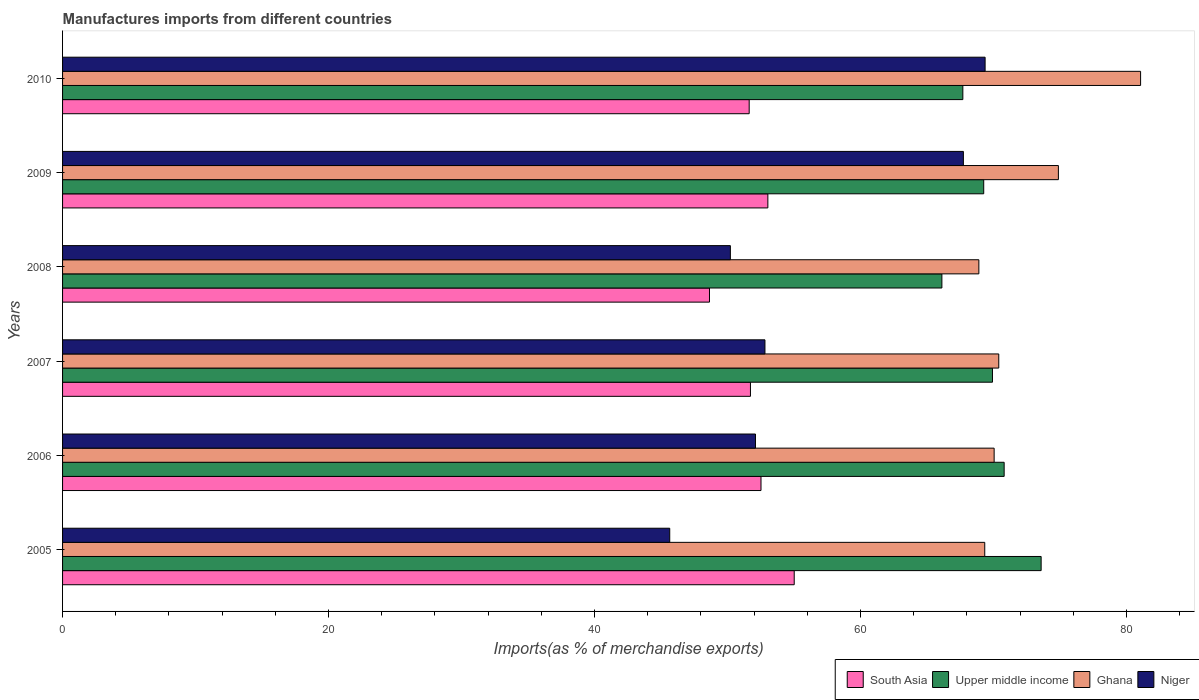How many groups of bars are there?
Your answer should be compact. 6. Are the number of bars per tick equal to the number of legend labels?
Give a very brief answer. Yes. What is the label of the 1st group of bars from the top?
Make the answer very short. 2010. What is the percentage of imports to different countries in Upper middle income in 2010?
Give a very brief answer. 67.7. Across all years, what is the maximum percentage of imports to different countries in Niger?
Keep it short and to the point. 69.37. Across all years, what is the minimum percentage of imports to different countries in South Asia?
Your answer should be very brief. 48.64. In which year was the percentage of imports to different countries in South Asia minimum?
Make the answer very short. 2008. What is the total percentage of imports to different countries in Ghana in the graph?
Keep it short and to the point. 434.63. What is the difference between the percentage of imports to different countries in South Asia in 2005 and that in 2009?
Give a very brief answer. 1.98. What is the difference between the percentage of imports to different countries in Ghana in 2006 and the percentage of imports to different countries in Niger in 2008?
Your answer should be very brief. 19.83. What is the average percentage of imports to different countries in Upper middle income per year?
Offer a very short reply. 69.56. In the year 2006, what is the difference between the percentage of imports to different countries in Ghana and percentage of imports to different countries in Upper middle income?
Keep it short and to the point. -0.75. In how many years, is the percentage of imports to different countries in Ghana greater than 64 %?
Give a very brief answer. 6. What is the ratio of the percentage of imports to different countries in Upper middle income in 2006 to that in 2008?
Provide a short and direct response. 1.07. Is the percentage of imports to different countries in Ghana in 2005 less than that in 2008?
Your answer should be compact. No. What is the difference between the highest and the second highest percentage of imports to different countries in South Asia?
Offer a terse response. 1.98. What is the difference between the highest and the lowest percentage of imports to different countries in Ghana?
Your response must be concise. 12.16. Is it the case that in every year, the sum of the percentage of imports to different countries in South Asia and percentage of imports to different countries in Upper middle income is greater than the sum of percentage of imports to different countries in Ghana and percentage of imports to different countries in Niger?
Make the answer very short. No. What does the 1st bar from the top in 2010 represents?
Offer a terse response. Niger. What does the 2nd bar from the bottom in 2009 represents?
Your answer should be compact. Upper middle income. How many bars are there?
Your response must be concise. 24. What is the difference between two consecutive major ticks on the X-axis?
Your answer should be compact. 20. Are the values on the major ticks of X-axis written in scientific E-notation?
Offer a very short reply. No. Does the graph contain any zero values?
Keep it short and to the point. No. Where does the legend appear in the graph?
Your response must be concise. Bottom right. What is the title of the graph?
Your answer should be very brief. Manufactures imports from different countries. Does "Georgia" appear as one of the legend labels in the graph?
Provide a succinct answer. No. What is the label or title of the X-axis?
Your answer should be compact. Imports(as % of merchandise exports). What is the Imports(as % of merchandise exports) of South Asia in 2005?
Provide a short and direct response. 55.02. What is the Imports(as % of merchandise exports) in Upper middle income in 2005?
Offer a terse response. 73.58. What is the Imports(as % of merchandise exports) of Ghana in 2005?
Ensure brevity in your answer.  69.34. What is the Imports(as % of merchandise exports) of Niger in 2005?
Offer a terse response. 45.66. What is the Imports(as % of merchandise exports) of South Asia in 2006?
Your response must be concise. 52.52. What is the Imports(as % of merchandise exports) of Upper middle income in 2006?
Keep it short and to the point. 70.8. What is the Imports(as % of merchandise exports) of Ghana in 2006?
Your answer should be compact. 70.05. What is the Imports(as % of merchandise exports) in Niger in 2006?
Provide a short and direct response. 52.1. What is the Imports(as % of merchandise exports) of South Asia in 2007?
Your answer should be very brief. 51.72. What is the Imports(as % of merchandise exports) in Upper middle income in 2007?
Make the answer very short. 69.92. What is the Imports(as % of merchandise exports) of Ghana in 2007?
Your response must be concise. 70.4. What is the Imports(as % of merchandise exports) of Niger in 2007?
Offer a very short reply. 52.82. What is the Imports(as % of merchandise exports) in South Asia in 2008?
Ensure brevity in your answer.  48.64. What is the Imports(as % of merchandise exports) in Upper middle income in 2008?
Offer a terse response. 66.12. What is the Imports(as % of merchandise exports) in Ghana in 2008?
Your response must be concise. 68.9. What is the Imports(as % of merchandise exports) of Niger in 2008?
Keep it short and to the point. 50.22. What is the Imports(as % of merchandise exports) in South Asia in 2009?
Give a very brief answer. 53.03. What is the Imports(as % of merchandise exports) in Upper middle income in 2009?
Provide a short and direct response. 69.27. What is the Imports(as % of merchandise exports) in Ghana in 2009?
Make the answer very short. 74.88. What is the Imports(as % of merchandise exports) of Niger in 2009?
Offer a terse response. 67.74. What is the Imports(as % of merchandise exports) in South Asia in 2010?
Your answer should be compact. 51.63. What is the Imports(as % of merchandise exports) of Upper middle income in 2010?
Provide a succinct answer. 67.7. What is the Imports(as % of merchandise exports) of Ghana in 2010?
Keep it short and to the point. 81.06. What is the Imports(as % of merchandise exports) in Niger in 2010?
Give a very brief answer. 69.37. Across all years, what is the maximum Imports(as % of merchandise exports) in South Asia?
Offer a terse response. 55.02. Across all years, what is the maximum Imports(as % of merchandise exports) of Upper middle income?
Make the answer very short. 73.58. Across all years, what is the maximum Imports(as % of merchandise exports) of Ghana?
Your answer should be very brief. 81.06. Across all years, what is the maximum Imports(as % of merchandise exports) in Niger?
Provide a short and direct response. 69.37. Across all years, what is the minimum Imports(as % of merchandise exports) of South Asia?
Your response must be concise. 48.64. Across all years, what is the minimum Imports(as % of merchandise exports) in Upper middle income?
Your answer should be compact. 66.12. Across all years, what is the minimum Imports(as % of merchandise exports) of Ghana?
Provide a succinct answer. 68.9. Across all years, what is the minimum Imports(as % of merchandise exports) of Niger?
Provide a short and direct response. 45.66. What is the total Imports(as % of merchandise exports) of South Asia in the graph?
Provide a succinct answer. 312.57. What is the total Imports(as % of merchandise exports) in Upper middle income in the graph?
Your response must be concise. 417.39. What is the total Imports(as % of merchandise exports) of Ghana in the graph?
Your answer should be very brief. 434.63. What is the total Imports(as % of merchandise exports) in Niger in the graph?
Give a very brief answer. 337.9. What is the difference between the Imports(as % of merchandise exports) of South Asia in 2005 and that in 2006?
Your answer should be very brief. 2.5. What is the difference between the Imports(as % of merchandise exports) in Upper middle income in 2005 and that in 2006?
Ensure brevity in your answer.  2.78. What is the difference between the Imports(as % of merchandise exports) of Ghana in 2005 and that in 2006?
Offer a terse response. -0.71. What is the difference between the Imports(as % of merchandise exports) in Niger in 2005 and that in 2006?
Give a very brief answer. -6.45. What is the difference between the Imports(as % of merchandise exports) in South Asia in 2005 and that in 2007?
Offer a terse response. 3.29. What is the difference between the Imports(as % of merchandise exports) of Upper middle income in 2005 and that in 2007?
Your response must be concise. 3.66. What is the difference between the Imports(as % of merchandise exports) in Ghana in 2005 and that in 2007?
Offer a very short reply. -1.05. What is the difference between the Imports(as % of merchandise exports) in Niger in 2005 and that in 2007?
Your answer should be very brief. -7.16. What is the difference between the Imports(as % of merchandise exports) in South Asia in 2005 and that in 2008?
Make the answer very short. 6.37. What is the difference between the Imports(as % of merchandise exports) in Upper middle income in 2005 and that in 2008?
Make the answer very short. 7.46. What is the difference between the Imports(as % of merchandise exports) of Ghana in 2005 and that in 2008?
Give a very brief answer. 0.44. What is the difference between the Imports(as % of merchandise exports) in Niger in 2005 and that in 2008?
Keep it short and to the point. -4.56. What is the difference between the Imports(as % of merchandise exports) of South Asia in 2005 and that in 2009?
Your answer should be very brief. 1.98. What is the difference between the Imports(as % of merchandise exports) of Upper middle income in 2005 and that in 2009?
Provide a short and direct response. 4.32. What is the difference between the Imports(as % of merchandise exports) in Ghana in 2005 and that in 2009?
Provide a short and direct response. -5.54. What is the difference between the Imports(as % of merchandise exports) in Niger in 2005 and that in 2009?
Offer a terse response. -22.08. What is the difference between the Imports(as % of merchandise exports) in South Asia in 2005 and that in 2010?
Offer a terse response. 3.39. What is the difference between the Imports(as % of merchandise exports) of Upper middle income in 2005 and that in 2010?
Your response must be concise. 5.89. What is the difference between the Imports(as % of merchandise exports) of Ghana in 2005 and that in 2010?
Your response must be concise. -11.72. What is the difference between the Imports(as % of merchandise exports) in Niger in 2005 and that in 2010?
Keep it short and to the point. -23.71. What is the difference between the Imports(as % of merchandise exports) of South Asia in 2006 and that in 2007?
Make the answer very short. 0.79. What is the difference between the Imports(as % of merchandise exports) in Upper middle income in 2006 and that in 2007?
Offer a very short reply. 0.88. What is the difference between the Imports(as % of merchandise exports) of Ghana in 2006 and that in 2007?
Offer a terse response. -0.35. What is the difference between the Imports(as % of merchandise exports) of Niger in 2006 and that in 2007?
Keep it short and to the point. -0.71. What is the difference between the Imports(as % of merchandise exports) in South Asia in 2006 and that in 2008?
Give a very brief answer. 3.87. What is the difference between the Imports(as % of merchandise exports) in Upper middle income in 2006 and that in 2008?
Give a very brief answer. 4.68. What is the difference between the Imports(as % of merchandise exports) of Ghana in 2006 and that in 2008?
Your response must be concise. 1.15. What is the difference between the Imports(as % of merchandise exports) of Niger in 2006 and that in 2008?
Give a very brief answer. 1.89. What is the difference between the Imports(as % of merchandise exports) of South Asia in 2006 and that in 2009?
Offer a terse response. -0.52. What is the difference between the Imports(as % of merchandise exports) of Upper middle income in 2006 and that in 2009?
Your response must be concise. 1.54. What is the difference between the Imports(as % of merchandise exports) in Ghana in 2006 and that in 2009?
Ensure brevity in your answer.  -4.83. What is the difference between the Imports(as % of merchandise exports) of Niger in 2006 and that in 2009?
Provide a succinct answer. -15.63. What is the difference between the Imports(as % of merchandise exports) in South Asia in 2006 and that in 2010?
Offer a very short reply. 0.89. What is the difference between the Imports(as % of merchandise exports) in Upper middle income in 2006 and that in 2010?
Give a very brief answer. 3.11. What is the difference between the Imports(as % of merchandise exports) in Ghana in 2006 and that in 2010?
Your answer should be compact. -11.01. What is the difference between the Imports(as % of merchandise exports) of Niger in 2006 and that in 2010?
Make the answer very short. -17.27. What is the difference between the Imports(as % of merchandise exports) in South Asia in 2007 and that in 2008?
Offer a very short reply. 3.08. What is the difference between the Imports(as % of merchandise exports) in Upper middle income in 2007 and that in 2008?
Provide a succinct answer. 3.8. What is the difference between the Imports(as % of merchandise exports) in Ghana in 2007 and that in 2008?
Provide a short and direct response. 1.5. What is the difference between the Imports(as % of merchandise exports) in Niger in 2007 and that in 2008?
Provide a short and direct response. 2.6. What is the difference between the Imports(as % of merchandise exports) of South Asia in 2007 and that in 2009?
Keep it short and to the point. -1.31. What is the difference between the Imports(as % of merchandise exports) of Upper middle income in 2007 and that in 2009?
Make the answer very short. 0.66. What is the difference between the Imports(as % of merchandise exports) in Ghana in 2007 and that in 2009?
Your answer should be very brief. -4.48. What is the difference between the Imports(as % of merchandise exports) of Niger in 2007 and that in 2009?
Provide a short and direct response. -14.92. What is the difference between the Imports(as % of merchandise exports) of South Asia in 2007 and that in 2010?
Your answer should be compact. 0.09. What is the difference between the Imports(as % of merchandise exports) in Upper middle income in 2007 and that in 2010?
Your response must be concise. 2.23. What is the difference between the Imports(as % of merchandise exports) in Ghana in 2007 and that in 2010?
Offer a terse response. -10.66. What is the difference between the Imports(as % of merchandise exports) of Niger in 2007 and that in 2010?
Provide a short and direct response. -16.55. What is the difference between the Imports(as % of merchandise exports) of South Asia in 2008 and that in 2009?
Your answer should be very brief. -4.39. What is the difference between the Imports(as % of merchandise exports) in Upper middle income in 2008 and that in 2009?
Your response must be concise. -3.15. What is the difference between the Imports(as % of merchandise exports) in Ghana in 2008 and that in 2009?
Offer a terse response. -5.98. What is the difference between the Imports(as % of merchandise exports) in Niger in 2008 and that in 2009?
Your response must be concise. -17.52. What is the difference between the Imports(as % of merchandise exports) in South Asia in 2008 and that in 2010?
Your answer should be very brief. -2.99. What is the difference between the Imports(as % of merchandise exports) of Upper middle income in 2008 and that in 2010?
Provide a short and direct response. -1.58. What is the difference between the Imports(as % of merchandise exports) of Ghana in 2008 and that in 2010?
Offer a very short reply. -12.16. What is the difference between the Imports(as % of merchandise exports) of Niger in 2008 and that in 2010?
Ensure brevity in your answer.  -19.15. What is the difference between the Imports(as % of merchandise exports) of South Asia in 2009 and that in 2010?
Keep it short and to the point. 1.4. What is the difference between the Imports(as % of merchandise exports) of Upper middle income in 2009 and that in 2010?
Give a very brief answer. 1.57. What is the difference between the Imports(as % of merchandise exports) of Ghana in 2009 and that in 2010?
Ensure brevity in your answer.  -6.18. What is the difference between the Imports(as % of merchandise exports) of Niger in 2009 and that in 2010?
Your answer should be very brief. -1.63. What is the difference between the Imports(as % of merchandise exports) of South Asia in 2005 and the Imports(as % of merchandise exports) of Upper middle income in 2006?
Provide a succinct answer. -15.79. What is the difference between the Imports(as % of merchandise exports) of South Asia in 2005 and the Imports(as % of merchandise exports) of Ghana in 2006?
Your response must be concise. -15.03. What is the difference between the Imports(as % of merchandise exports) in South Asia in 2005 and the Imports(as % of merchandise exports) in Niger in 2006?
Your answer should be very brief. 2.91. What is the difference between the Imports(as % of merchandise exports) in Upper middle income in 2005 and the Imports(as % of merchandise exports) in Ghana in 2006?
Provide a succinct answer. 3.53. What is the difference between the Imports(as % of merchandise exports) of Upper middle income in 2005 and the Imports(as % of merchandise exports) of Niger in 2006?
Give a very brief answer. 21.48. What is the difference between the Imports(as % of merchandise exports) of Ghana in 2005 and the Imports(as % of merchandise exports) of Niger in 2006?
Ensure brevity in your answer.  17.24. What is the difference between the Imports(as % of merchandise exports) in South Asia in 2005 and the Imports(as % of merchandise exports) in Upper middle income in 2007?
Provide a short and direct response. -14.91. What is the difference between the Imports(as % of merchandise exports) in South Asia in 2005 and the Imports(as % of merchandise exports) in Ghana in 2007?
Offer a terse response. -15.38. What is the difference between the Imports(as % of merchandise exports) in South Asia in 2005 and the Imports(as % of merchandise exports) in Niger in 2007?
Your answer should be compact. 2.2. What is the difference between the Imports(as % of merchandise exports) in Upper middle income in 2005 and the Imports(as % of merchandise exports) in Ghana in 2007?
Provide a short and direct response. 3.19. What is the difference between the Imports(as % of merchandise exports) of Upper middle income in 2005 and the Imports(as % of merchandise exports) of Niger in 2007?
Your response must be concise. 20.77. What is the difference between the Imports(as % of merchandise exports) of Ghana in 2005 and the Imports(as % of merchandise exports) of Niger in 2007?
Give a very brief answer. 16.53. What is the difference between the Imports(as % of merchandise exports) of South Asia in 2005 and the Imports(as % of merchandise exports) of Upper middle income in 2008?
Make the answer very short. -11.1. What is the difference between the Imports(as % of merchandise exports) in South Asia in 2005 and the Imports(as % of merchandise exports) in Ghana in 2008?
Make the answer very short. -13.88. What is the difference between the Imports(as % of merchandise exports) in South Asia in 2005 and the Imports(as % of merchandise exports) in Niger in 2008?
Offer a terse response. 4.8. What is the difference between the Imports(as % of merchandise exports) of Upper middle income in 2005 and the Imports(as % of merchandise exports) of Ghana in 2008?
Give a very brief answer. 4.68. What is the difference between the Imports(as % of merchandise exports) in Upper middle income in 2005 and the Imports(as % of merchandise exports) in Niger in 2008?
Your response must be concise. 23.37. What is the difference between the Imports(as % of merchandise exports) of Ghana in 2005 and the Imports(as % of merchandise exports) of Niger in 2008?
Give a very brief answer. 19.13. What is the difference between the Imports(as % of merchandise exports) of South Asia in 2005 and the Imports(as % of merchandise exports) of Upper middle income in 2009?
Your response must be concise. -14.25. What is the difference between the Imports(as % of merchandise exports) of South Asia in 2005 and the Imports(as % of merchandise exports) of Ghana in 2009?
Provide a succinct answer. -19.86. What is the difference between the Imports(as % of merchandise exports) of South Asia in 2005 and the Imports(as % of merchandise exports) of Niger in 2009?
Offer a terse response. -12.72. What is the difference between the Imports(as % of merchandise exports) in Upper middle income in 2005 and the Imports(as % of merchandise exports) in Ghana in 2009?
Provide a short and direct response. -1.3. What is the difference between the Imports(as % of merchandise exports) of Upper middle income in 2005 and the Imports(as % of merchandise exports) of Niger in 2009?
Give a very brief answer. 5.85. What is the difference between the Imports(as % of merchandise exports) of Ghana in 2005 and the Imports(as % of merchandise exports) of Niger in 2009?
Your response must be concise. 1.61. What is the difference between the Imports(as % of merchandise exports) of South Asia in 2005 and the Imports(as % of merchandise exports) of Upper middle income in 2010?
Provide a succinct answer. -12.68. What is the difference between the Imports(as % of merchandise exports) of South Asia in 2005 and the Imports(as % of merchandise exports) of Ghana in 2010?
Your response must be concise. -26.05. What is the difference between the Imports(as % of merchandise exports) in South Asia in 2005 and the Imports(as % of merchandise exports) in Niger in 2010?
Keep it short and to the point. -14.35. What is the difference between the Imports(as % of merchandise exports) of Upper middle income in 2005 and the Imports(as % of merchandise exports) of Ghana in 2010?
Keep it short and to the point. -7.48. What is the difference between the Imports(as % of merchandise exports) of Upper middle income in 2005 and the Imports(as % of merchandise exports) of Niger in 2010?
Provide a short and direct response. 4.21. What is the difference between the Imports(as % of merchandise exports) in Ghana in 2005 and the Imports(as % of merchandise exports) in Niger in 2010?
Make the answer very short. -0.03. What is the difference between the Imports(as % of merchandise exports) in South Asia in 2006 and the Imports(as % of merchandise exports) in Upper middle income in 2007?
Keep it short and to the point. -17.4. What is the difference between the Imports(as % of merchandise exports) of South Asia in 2006 and the Imports(as % of merchandise exports) of Ghana in 2007?
Offer a very short reply. -17.88. What is the difference between the Imports(as % of merchandise exports) of South Asia in 2006 and the Imports(as % of merchandise exports) of Niger in 2007?
Your answer should be compact. -0.3. What is the difference between the Imports(as % of merchandise exports) in Upper middle income in 2006 and the Imports(as % of merchandise exports) in Ghana in 2007?
Give a very brief answer. 0.41. What is the difference between the Imports(as % of merchandise exports) in Upper middle income in 2006 and the Imports(as % of merchandise exports) in Niger in 2007?
Keep it short and to the point. 17.99. What is the difference between the Imports(as % of merchandise exports) in Ghana in 2006 and the Imports(as % of merchandise exports) in Niger in 2007?
Your response must be concise. 17.23. What is the difference between the Imports(as % of merchandise exports) of South Asia in 2006 and the Imports(as % of merchandise exports) of Upper middle income in 2008?
Keep it short and to the point. -13.6. What is the difference between the Imports(as % of merchandise exports) of South Asia in 2006 and the Imports(as % of merchandise exports) of Ghana in 2008?
Ensure brevity in your answer.  -16.38. What is the difference between the Imports(as % of merchandise exports) in South Asia in 2006 and the Imports(as % of merchandise exports) in Niger in 2008?
Make the answer very short. 2.3. What is the difference between the Imports(as % of merchandise exports) of Upper middle income in 2006 and the Imports(as % of merchandise exports) of Ghana in 2008?
Offer a very short reply. 1.9. What is the difference between the Imports(as % of merchandise exports) of Upper middle income in 2006 and the Imports(as % of merchandise exports) of Niger in 2008?
Give a very brief answer. 20.59. What is the difference between the Imports(as % of merchandise exports) of Ghana in 2006 and the Imports(as % of merchandise exports) of Niger in 2008?
Give a very brief answer. 19.83. What is the difference between the Imports(as % of merchandise exports) in South Asia in 2006 and the Imports(as % of merchandise exports) in Upper middle income in 2009?
Keep it short and to the point. -16.75. What is the difference between the Imports(as % of merchandise exports) in South Asia in 2006 and the Imports(as % of merchandise exports) in Ghana in 2009?
Give a very brief answer. -22.36. What is the difference between the Imports(as % of merchandise exports) of South Asia in 2006 and the Imports(as % of merchandise exports) of Niger in 2009?
Your response must be concise. -15.22. What is the difference between the Imports(as % of merchandise exports) of Upper middle income in 2006 and the Imports(as % of merchandise exports) of Ghana in 2009?
Give a very brief answer. -4.08. What is the difference between the Imports(as % of merchandise exports) of Upper middle income in 2006 and the Imports(as % of merchandise exports) of Niger in 2009?
Offer a terse response. 3.07. What is the difference between the Imports(as % of merchandise exports) of Ghana in 2006 and the Imports(as % of merchandise exports) of Niger in 2009?
Offer a terse response. 2.31. What is the difference between the Imports(as % of merchandise exports) in South Asia in 2006 and the Imports(as % of merchandise exports) in Upper middle income in 2010?
Offer a very short reply. -15.18. What is the difference between the Imports(as % of merchandise exports) in South Asia in 2006 and the Imports(as % of merchandise exports) in Ghana in 2010?
Ensure brevity in your answer.  -28.54. What is the difference between the Imports(as % of merchandise exports) of South Asia in 2006 and the Imports(as % of merchandise exports) of Niger in 2010?
Give a very brief answer. -16.85. What is the difference between the Imports(as % of merchandise exports) of Upper middle income in 2006 and the Imports(as % of merchandise exports) of Ghana in 2010?
Your answer should be compact. -10.26. What is the difference between the Imports(as % of merchandise exports) of Upper middle income in 2006 and the Imports(as % of merchandise exports) of Niger in 2010?
Your answer should be compact. 1.43. What is the difference between the Imports(as % of merchandise exports) in Ghana in 2006 and the Imports(as % of merchandise exports) in Niger in 2010?
Your answer should be compact. 0.68. What is the difference between the Imports(as % of merchandise exports) of South Asia in 2007 and the Imports(as % of merchandise exports) of Upper middle income in 2008?
Provide a short and direct response. -14.4. What is the difference between the Imports(as % of merchandise exports) of South Asia in 2007 and the Imports(as % of merchandise exports) of Ghana in 2008?
Offer a very short reply. -17.18. What is the difference between the Imports(as % of merchandise exports) in South Asia in 2007 and the Imports(as % of merchandise exports) in Niger in 2008?
Provide a succinct answer. 1.51. What is the difference between the Imports(as % of merchandise exports) in Upper middle income in 2007 and the Imports(as % of merchandise exports) in Ghana in 2008?
Your answer should be compact. 1.02. What is the difference between the Imports(as % of merchandise exports) in Upper middle income in 2007 and the Imports(as % of merchandise exports) in Niger in 2008?
Ensure brevity in your answer.  19.71. What is the difference between the Imports(as % of merchandise exports) of Ghana in 2007 and the Imports(as % of merchandise exports) of Niger in 2008?
Your response must be concise. 20.18. What is the difference between the Imports(as % of merchandise exports) of South Asia in 2007 and the Imports(as % of merchandise exports) of Upper middle income in 2009?
Offer a very short reply. -17.54. What is the difference between the Imports(as % of merchandise exports) in South Asia in 2007 and the Imports(as % of merchandise exports) in Ghana in 2009?
Your answer should be compact. -23.16. What is the difference between the Imports(as % of merchandise exports) in South Asia in 2007 and the Imports(as % of merchandise exports) in Niger in 2009?
Offer a very short reply. -16.01. What is the difference between the Imports(as % of merchandise exports) of Upper middle income in 2007 and the Imports(as % of merchandise exports) of Ghana in 2009?
Provide a short and direct response. -4.96. What is the difference between the Imports(as % of merchandise exports) of Upper middle income in 2007 and the Imports(as % of merchandise exports) of Niger in 2009?
Your response must be concise. 2.19. What is the difference between the Imports(as % of merchandise exports) in Ghana in 2007 and the Imports(as % of merchandise exports) in Niger in 2009?
Provide a succinct answer. 2.66. What is the difference between the Imports(as % of merchandise exports) in South Asia in 2007 and the Imports(as % of merchandise exports) in Upper middle income in 2010?
Keep it short and to the point. -15.97. What is the difference between the Imports(as % of merchandise exports) of South Asia in 2007 and the Imports(as % of merchandise exports) of Ghana in 2010?
Make the answer very short. -29.34. What is the difference between the Imports(as % of merchandise exports) in South Asia in 2007 and the Imports(as % of merchandise exports) in Niger in 2010?
Ensure brevity in your answer.  -17.65. What is the difference between the Imports(as % of merchandise exports) in Upper middle income in 2007 and the Imports(as % of merchandise exports) in Ghana in 2010?
Make the answer very short. -11.14. What is the difference between the Imports(as % of merchandise exports) in Upper middle income in 2007 and the Imports(as % of merchandise exports) in Niger in 2010?
Ensure brevity in your answer.  0.55. What is the difference between the Imports(as % of merchandise exports) in Ghana in 2007 and the Imports(as % of merchandise exports) in Niger in 2010?
Your response must be concise. 1.03. What is the difference between the Imports(as % of merchandise exports) of South Asia in 2008 and the Imports(as % of merchandise exports) of Upper middle income in 2009?
Make the answer very short. -20.62. What is the difference between the Imports(as % of merchandise exports) of South Asia in 2008 and the Imports(as % of merchandise exports) of Ghana in 2009?
Provide a succinct answer. -26.24. What is the difference between the Imports(as % of merchandise exports) of South Asia in 2008 and the Imports(as % of merchandise exports) of Niger in 2009?
Your answer should be compact. -19.09. What is the difference between the Imports(as % of merchandise exports) of Upper middle income in 2008 and the Imports(as % of merchandise exports) of Ghana in 2009?
Ensure brevity in your answer.  -8.76. What is the difference between the Imports(as % of merchandise exports) in Upper middle income in 2008 and the Imports(as % of merchandise exports) in Niger in 2009?
Offer a terse response. -1.62. What is the difference between the Imports(as % of merchandise exports) in Ghana in 2008 and the Imports(as % of merchandise exports) in Niger in 2009?
Give a very brief answer. 1.16. What is the difference between the Imports(as % of merchandise exports) in South Asia in 2008 and the Imports(as % of merchandise exports) in Upper middle income in 2010?
Make the answer very short. -19.05. What is the difference between the Imports(as % of merchandise exports) of South Asia in 2008 and the Imports(as % of merchandise exports) of Ghana in 2010?
Your response must be concise. -32.42. What is the difference between the Imports(as % of merchandise exports) of South Asia in 2008 and the Imports(as % of merchandise exports) of Niger in 2010?
Make the answer very short. -20.73. What is the difference between the Imports(as % of merchandise exports) of Upper middle income in 2008 and the Imports(as % of merchandise exports) of Ghana in 2010?
Your answer should be very brief. -14.94. What is the difference between the Imports(as % of merchandise exports) of Upper middle income in 2008 and the Imports(as % of merchandise exports) of Niger in 2010?
Your answer should be very brief. -3.25. What is the difference between the Imports(as % of merchandise exports) of Ghana in 2008 and the Imports(as % of merchandise exports) of Niger in 2010?
Offer a terse response. -0.47. What is the difference between the Imports(as % of merchandise exports) of South Asia in 2009 and the Imports(as % of merchandise exports) of Upper middle income in 2010?
Make the answer very short. -14.66. What is the difference between the Imports(as % of merchandise exports) of South Asia in 2009 and the Imports(as % of merchandise exports) of Ghana in 2010?
Give a very brief answer. -28.03. What is the difference between the Imports(as % of merchandise exports) of South Asia in 2009 and the Imports(as % of merchandise exports) of Niger in 2010?
Offer a very short reply. -16.34. What is the difference between the Imports(as % of merchandise exports) in Upper middle income in 2009 and the Imports(as % of merchandise exports) in Ghana in 2010?
Make the answer very short. -11.8. What is the difference between the Imports(as % of merchandise exports) of Upper middle income in 2009 and the Imports(as % of merchandise exports) of Niger in 2010?
Your answer should be very brief. -0.1. What is the difference between the Imports(as % of merchandise exports) of Ghana in 2009 and the Imports(as % of merchandise exports) of Niger in 2010?
Your response must be concise. 5.51. What is the average Imports(as % of merchandise exports) of South Asia per year?
Give a very brief answer. 52.09. What is the average Imports(as % of merchandise exports) of Upper middle income per year?
Offer a very short reply. 69.56. What is the average Imports(as % of merchandise exports) of Ghana per year?
Your response must be concise. 72.44. What is the average Imports(as % of merchandise exports) of Niger per year?
Your response must be concise. 56.32. In the year 2005, what is the difference between the Imports(as % of merchandise exports) in South Asia and Imports(as % of merchandise exports) in Upper middle income?
Keep it short and to the point. -18.57. In the year 2005, what is the difference between the Imports(as % of merchandise exports) in South Asia and Imports(as % of merchandise exports) in Ghana?
Your response must be concise. -14.33. In the year 2005, what is the difference between the Imports(as % of merchandise exports) of South Asia and Imports(as % of merchandise exports) of Niger?
Offer a very short reply. 9.36. In the year 2005, what is the difference between the Imports(as % of merchandise exports) in Upper middle income and Imports(as % of merchandise exports) in Ghana?
Make the answer very short. 4.24. In the year 2005, what is the difference between the Imports(as % of merchandise exports) in Upper middle income and Imports(as % of merchandise exports) in Niger?
Your response must be concise. 27.93. In the year 2005, what is the difference between the Imports(as % of merchandise exports) of Ghana and Imports(as % of merchandise exports) of Niger?
Keep it short and to the point. 23.69. In the year 2006, what is the difference between the Imports(as % of merchandise exports) of South Asia and Imports(as % of merchandise exports) of Upper middle income?
Give a very brief answer. -18.28. In the year 2006, what is the difference between the Imports(as % of merchandise exports) of South Asia and Imports(as % of merchandise exports) of Ghana?
Give a very brief answer. -17.53. In the year 2006, what is the difference between the Imports(as % of merchandise exports) in South Asia and Imports(as % of merchandise exports) in Niger?
Ensure brevity in your answer.  0.41. In the year 2006, what is the difference between the Imports(as % of merchandise exports) in Upper middle income and Imports(as % of merchandise exports) in Ghana?
Ensure brevity in your answer.  0.75. In the year 2006, what is the difference between the Imports(as % of merchandise exports) in Upper middle income and Imports(as % of merchandise exports) in Niger?
Make the answer very short. 18.7. In the year 2006, what is the difference between the Imports(as % of merchandise exports) in Ghana and Imports(as % of merchandise exports) in Niger?
Ensure brevity in your answer.  17.95. In the year 2007, what is the difference between the Imports(as % of merchandise exports) of South Asia and Imports(as % of merchandise exports) of Upper middle income?
Offer a very short reply. -18.2. In the year 2007, what is the difference between the Imports(as % of merchandise exports) in South Asia and Imports(as % of merchandise exports) in Ghana?
Ensure brevity in your answer.  -18.67. In the year 2007, what is the difference between the Imports(as % of merchandise exports) of South Asia and Imports(as % of merchandise exports) of Niger?
Keep it short and to the point. -1.09. In the year 2007, what is the difference between the Imports(as % of merchandise exports) in Upper middle income and Imports(as % of merchandise exports) in Ghana?
Your answer should be compact. -0.47. In the year 2007, what is the difference between the Imports(as % of merchandise exports) in Upper middle income and Imports(as % of merchandise exports) in Niger?
Your response must be concise. 17.11. In the year 2007, what is the difference between the Imports(as % of merchandise exports) of Ghana and Imports(as % of merchandise exports) of Niger?
Your answer should be compact. 17.58. In the year 2008, what is the difference between the Imports(as % of merchandise exports) in South Asia and Imports(as % of merchandise exports) in Upper middle income?
Your answer should be compact. -17.48. In the year 2008, what is the difference between the Imports(as % of merchandise exports) of South Asia and Imports(as % of merchandise exports) of Ghana?
Your answer should be compact. -20.26. In the year 2008, what is the difference between the Imports(as % of merchandise exports) of South Asia and Imports(as % of merchandise exports) of Niger?
Offer a terse response. -1.57. In the year 2008, what is the difference between the Imports(as % of merchandise exports) of Upper middle income and Imports(as % of merchandise exports) of Ghana?
Provide a succinct answer. -2.78. In the year 2008, what is the difference between the Imports(as % of merchandise exports) in Upper middle income and Imports(as % of merchandise exports) in Niger?
Provide a short and direct response. 15.9. In the year 2008, what is the difference between the Imports(as % of merchandise exports) of Ghana and Imports(as % of merchandise exports) of Niger?
Provide a succinct answer. 18.68. In the year 2009, what is the difference between the Imports(as % of merchandise exports) in South Asia and Imports(as % of merchandise exports) in Upper middle income?
Provide a short and direct response. -16.23. In the year 2009, what is the difference between the Imports(as % of merchandise exports) of South Asia and Imports(as % of merchandise exports) of Ghana?
Provide a succinct answer. -21.85. In the year 2009, what is the difference between the Imports(as % of merchandise exports) in South Asia and Imports(as % of merchandise exports) in Niger?
Provide a succinct answer. -14.7. In the year 2009, what is the difference between the Imports(as % of merchandise exports) in Upper middle income and Imports(as % of merchandise exports) in Ghana?
Provide a short and direct response. -5.61. In the year 2009, what is the difference between the Imports(as % of merchandise exports) in Upper middle income and Imports(as % of merchandise exports) in Niger?
Give a very brief answer. 1.53. In the year 2009, what is the difference between the Imports(as % of merchandise exports) of Ghana and Imports(as % of merchandise exports) of Niger?
Keep it short and to the point. 7.14. In the year 2010, what is the difference between the Imports(as % of merchandise exports) of South Asia and Imports(as % of merchandise exports) of Upper middle income?
Give a very brief answer. -16.07. In the year 2010, what is the difference between the Imports(as % of merchandise exports) of South Asia and Imports(as % of merchandise exports) of Ghana?
Give a very brief answer. -29.43. In the year 2010, what is the difference between the Imports(as % of merchandise exports) of South Asia and Imports(as % of merchandise exports) of Niger?
Keep it short and to the point. -17.74. In the year 2010, what is the difference between the Imports(as % of merchandise exports) in Upper middle income and Imports(as % of merchandise exports) in Ghana?
Give a very brief answer. -13.37. In the year 2010, what is the difference between the Imports(as % of merchandise exports) in Upper middle income and Imports(as % of merchandise exports) in Niger?
Keep it short and to the point. -1.67. In the year 2010, what is the difference between the Imports(as % of merchandise exports) of Ghana and Imports(as % of merchandise exports) of Niger?
Your answer should be compact. 11.69. What is the ratio of the Imports(as % of merchandise exports) of South Asia in 2005 to that in 2006?
Give a very brief answer. 1.05. What is the ratio of the Imports(as % of merchandise exports) of Upper middle income in 2005 to that in 2006?
Offer a very short reply. 1.04. What is the ratio of the Imports(as % of merchandise exports) in Ghana in 2005 to that in 2006?
Ensure brevity in your answer.  0.99. What is the ratio of the Imports(as % of merchandise exports) in Niger in 2005 to that in 2006?
Make the answer very short. 0.88. What is the ratio of the Imports(as % of merchandise exports) of South Asia in 2005 to that in 2007?
Provide a succinct answer. 1.06. What is the ratio of the Imports(as % of merchandise exports) in Upper middle income in 2005 to that in 2007?
Offer a very short reply. 1.05. What is the ratio of the Imports(as % of merchandise exports) in Niger in 2005 to that in 2007?
Provide a succinct answer. 0.86. What is the ratio of the Imports(as % of merchandise exports) of South Asia in 2005 to that in 2008?
Your response must be concise. 1.13. What is the ratio of the Imports(as % of merchandise exports) in Upper middle income in 2005 to that in 2008?
Provide a short and direct response. 1.11. What is the ratio of the Imports(as % of merchandise exports) of Ghana in 2005 to that in 2008?
Make the answer very short. 1.01. What is the ratio of the Imports(as % of merchandise exports) of Niger in 2005 to that in 2008?
Make the answer very short. 0.91. What is the ratio of the Imports(as % of merchandise exports) in South Asia in 2005 to that in 2009?
Provide a succinct answer. 1.04. What is the ratio of the Imports(as % of merchandise exports) of Upper middle income in 2005 to that in 2009?
Your response must be concise. 1.06. What is the ratio of the Imports(as % of merchandise exports) of Ghana in 2005 to that in 2009?
Make the answer very short. 0.93. What is the ratio of the Imports(as % of merchandise exports) of Niger in 2005 to that in 2009?
Your answer should be very brief. 0.67. What is the ratio of the Imports(as % of merchandise exports) in South Asia in 2005 to that in 2010?
Your answer should be very brief. 1.07. What is the ratio of the Imports(as % of merchandise exports) in Upper middle income in 2005 to that in 2010?
Your answer should be very brief. 1.09. What is the ratio of the Imports(as % of merchandise exports) of Ghana in 2005 to that in 2010?
Your answer should be very brief. 0.86. What is the ratio of the Imports(as % of merchandise exports) of Niger in 2005 to that in 2010?
Ensure brevity in your answer.  0.66. What is the ratio of the Imports(as % of merchandise exports) in South Asia in 2006 to that in 2007?
Provide a succinct answer. 1.02. What is the ratio of the Imports(as % of merchandise exports) in Upper middle income in 2006 to that in 2007?
Your answer should be compact. 1.01. What is the ratio of the Imports(as % of merchandise exports) in Ghana in 2006 to that in 2007?
Your answer should be very brief. 1. What is the ratio of the Imports(as % of merchandise exports) in Niger in 2006 to that in 2007?
Give a very brief answer. 0.99. What is the ratio of the Imports(as % of merchandise exports) of South Asia in 2006 to that in 2008?
Provide a succinct answer. 1.08. What is the ratio of the Imports(as % of merchandise exports) in Upper middle income in 2006 to that in 2008?
Your answer should be very brief. 1.07. What is the ratio of the Imports(as % of merchandise exports) of Ghana in 2006 to that in 2008?
Give a very brief answer. 1.02. What is the ratio of the Imports(as % of merchandise exports) in Niger in 2006 to that in 2008?
Your answer should be compact. 1.04. What is the ratio of the Imports(as % of merchandise exports) in South Asia in 2006 to that in 2009?
Keep it short and to the point. 0.99. What is the ratio of the Imports(as % of merchandise exports) of Upper middle income in 2006 to that in 2009?
Ensure brevity in your answer.  1.02. What is the ratio of the Imports(as % of merchandise exports) of Ghana in 2006 to that in 2009?
Give a very brief answer. 0.94. What is the ratio of the Imports(as % of merchandise exports) of Niger in 2006 to that in 2009?
Offer a terse response. 0.77. What is the ratio of the Imports(as % of merchandise exports) of South Asia in 2006 to that in 2010?
Your answer should be compact. 1.02. What is the ratio of the Imports(as % of merchandise exports) in Upper middle income in 2006 to that in 2010?
Your answer should be very brief. 1.05. What is the ratio of the Imports(as % of merchandise exports) in Ghana in 2006 to that in 2010?
Your answer should be very brief. 0.86. What is the ratio of the Imports(as % of merchandise exports) in Niger in 2006 to that in 2010?
Make the answer very short. 0.75. What is the ratio of the Imports(as % of merchandise exports) in South Asia in 2007 to that in 2008?
Keep it short and to the point. 1.06. What is the ratio of the Imports(as % of merchandise exports) of Upper middle income in 2007 to that in 2008?
Give a very brief answer. 1.06. What is the ratio of the Imports(as % of merchandise exports) in Ghana in 2007 to that in 2008?
Your response must be concise. 1.02. What is the ratio of the Imports(as % of merchandise exports) of Niger in 2007 to that in 2008?
Your answer should be compact. 1.05. What is the ratio of the Imports(as % of merchandise exports) of South Asia in 2007 to that in 2009?
Make the answer very short. 0.98. What is the ratio of the Imports(as % of merchandise exports) in Upper middle income in 2007 to that in 2009?
Make the answer very short. 1.01. What is the ratio of the Imports(as % of merchandise exports) of Ghana in 2007 to that in 2009?
Ensure brevity in your answer.  0.94. What is the ratio of the Imports(as % of merchandise exports) in Niger in 2007 to that in 2009?
Provide a succinct answer. 0.78. What is the ratio of the Imports(as % of merchandise exports) of South Asia in 2007 to that in 2010?
Offer a very short reply. 1. What is the ratio of the Imports(as % of merchandise exports) in Upper middle income in 2007 to that in 2010?
Your answer should be very brief. 1.03. What is the ratio of the Imports(as % of merchandise exports) in Ghana in 2007 to that in 2010?
Your answer should be very brief. 0.87. What is the ratio of the Imports(as % of merchandise exports) of Niger in 2007 to that in 2010?
Your answer should be compact. 0.76. What is the ratio of the Imports(as % of merchandise exports) of South Asia in 2008 to that in 2009?
Your answer should be compact. 0.92. What is the ratio of the Imports(as % of merchandise exports) of Upper middle income in 2008 to that in 2009?
Make the answer very short. 0.95. What is the ratio of the Imports(as % of merchandise exports) of Ghana in 2008 to that in 2009?
Offer a terse response. 0.92. What is the ratio of the Imports(as % of merchandise exports) of Niger in 2008 to that in 2009?
Provide a succinct answer. 0.74. What is the ratio of the Imports(as % of merchandise exports) in South Asia in 2008 to that in 2010?
Your response must be concise. 0.94. What is the ratio of the Imports(as % of merchandise exports) of Upper middle income in 2008 to that in 2010?
Your answer should be compact. 0.98. What is the ratio of the Imports(as % of merchandise exports) in Ghana in 2008 to that in 2010?
Offer a very short reply. 0.85. What is the ratio of the Imports(as % of merchandise exports) of Niger in 2008 to that in 2010?
Keep it short and to the point. 0.72. What is the ratio of the Imports(as % of merchandise exports) in South Asia in 2009 to that in 2010?
Offer a very short reply. 1.03. What is the ratio of the Imports(as % of merchandise exports) in Upper middle income in 2009 to that in 2010?
Your answer should be compact. 1.02. What is the ratio of the Imports(as % of merchandise exports) in Ghana in 2009 to that in 2010?
Your answer should be very brief. 0.92. What is the ratio of the Imports(as % of merchandise exports) of Niger in 2009 to that in 2010?
Your answer should be compact. 0.98. What is the difference between the highest and the second highest Imports(as % of merchandise exports) of South Asia?
Your answer should be very brief. 1.98. What is the difference between the highest and the second highest Imports(as % of merchandise exports) in Upper middle income?
Offer a terse response. 2.78. What is the difference between the highest and the second highest Imports(as % of merchandise exports) of Ghana?
Your answer should be compact. 6.18. What is the difference between the highest and the second highest Imports(as % of merchandise exports) of Niger?
Give a very brief answer. 1.63. What is the difference between the highest and the lowest Imports(as % of merchandise exports) in South Asia?
Your answer should be very brief. 6.37. What is the difference between the highest and the lowest Imports(as % of merchandise exports) of Upper middle income?
Keep it short and to the point. 7.46. What is the difference between the highest and the lowest Imports(as % of merchandise exports) of Ghana?
Your answer should be compact. 12.16. What is the difference between the highest and the lowest Imports(as % of merchandise exports) in Niger?
Offer a terse response. 23.71. 